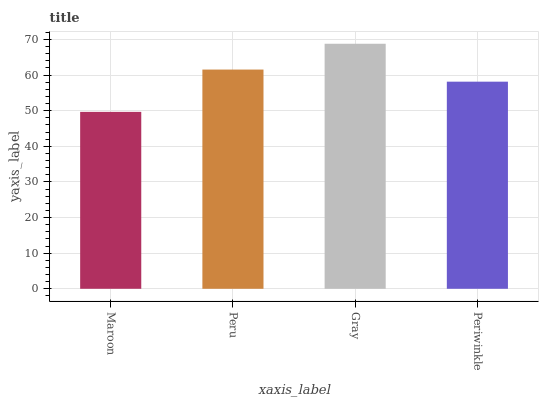Is Maroon the minimum?
Answer yes or no. Yes. Is Gray the maximum?
Answer yes or no. Yes. Is Peru the minimum?
Answer yes or no. No. Is Peru the maximum?
Answer yes or no. No. Is Peru greater than Maroon?
Answer yes or no. Yes. Is Maroon less than Peru?
Answer yes or no. Yes. Is Maroon greater than Peru?
Answer yes or no. No. Is Peru less than Maroon?
Answer yes or no. No. Is Peru the high median?
Answer yes or no. Yes. Is Periwinkle the low median?
Answer yes or no. Yes. Is Periwinkle the high median?
Answer yes or no. No. Is Gray the low median?
Answer yes or no. No. 